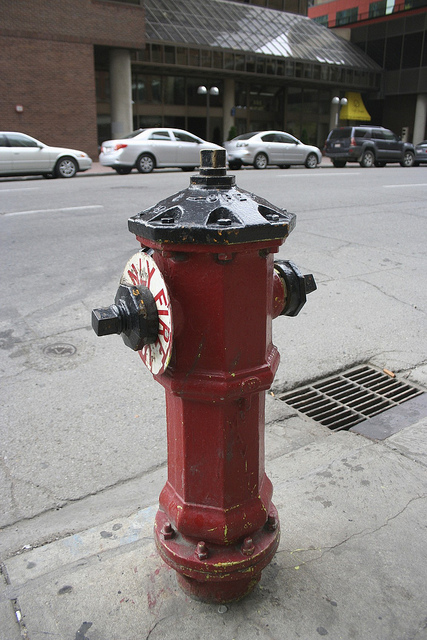Please extract the text content from this image. NLY FIRE 